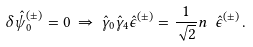<formula> <loc_0><loc_0><loc_500><loc_500>\delta \hat { \psi } _ { 0 } ^ { ( \pm ) } = 0 \, \Rightarrow \, \hat { \gamma } _ { 0 } \hat { \gamma } _ { 4 } \hat { \epsilon } ^ { ( \pm ) } = { \frac { 1 } { \sqrt { 2 } } } n \ \hat { \epsilon } ^ { ( \pm ) } \, .</formula> 